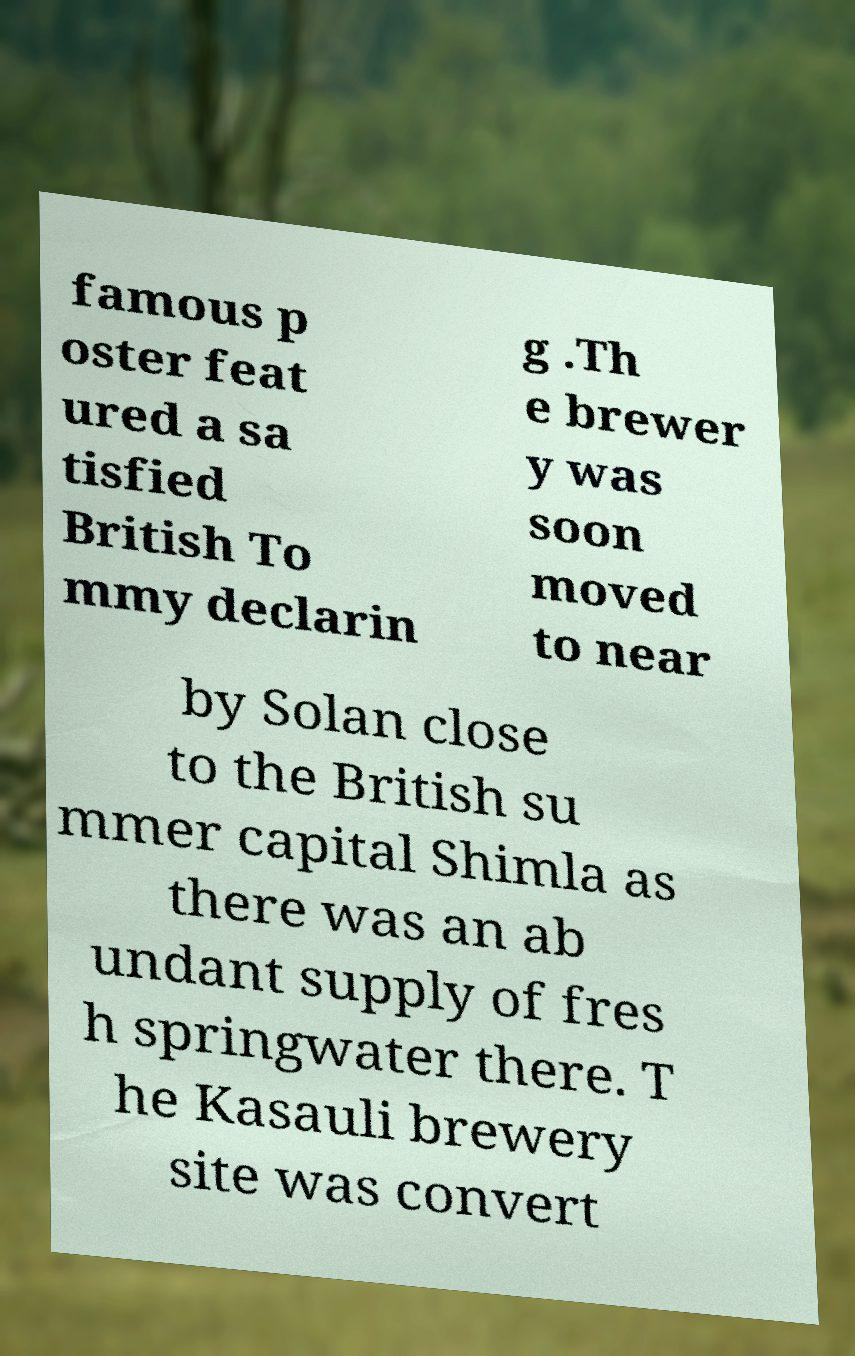Can you read and provide the text displayed in the image?This photo seems to have some interesting text. Can you extract and type it out for me? famous p oster feat ured a sa tisfied British To mmy declarin g .Th e brewer y was soon moved to near by Solan close to the British su mmer capital Shimla as there was an ab undant supply of fres h springwater there. T he Kasauli brewery site was convert 